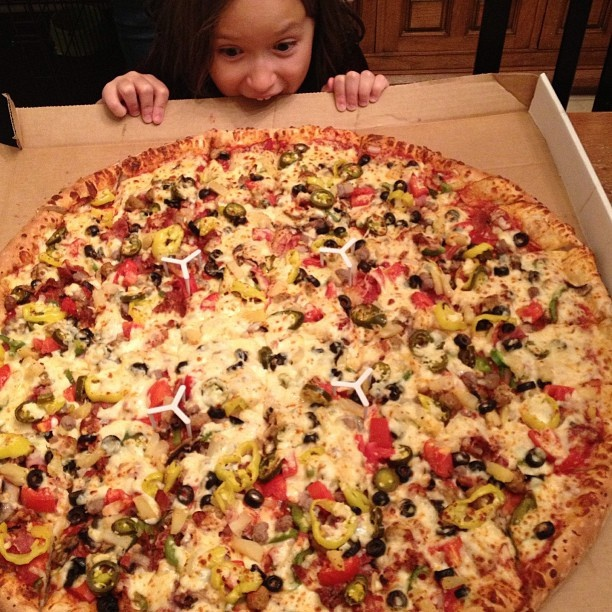Describe the objects in this image and their specific colors. I can see pizza in black, tan, brown, and maroon tones, people in black, brown, and maroon tones, and dining table in black, brown, maroon, and gray tones in this image. 